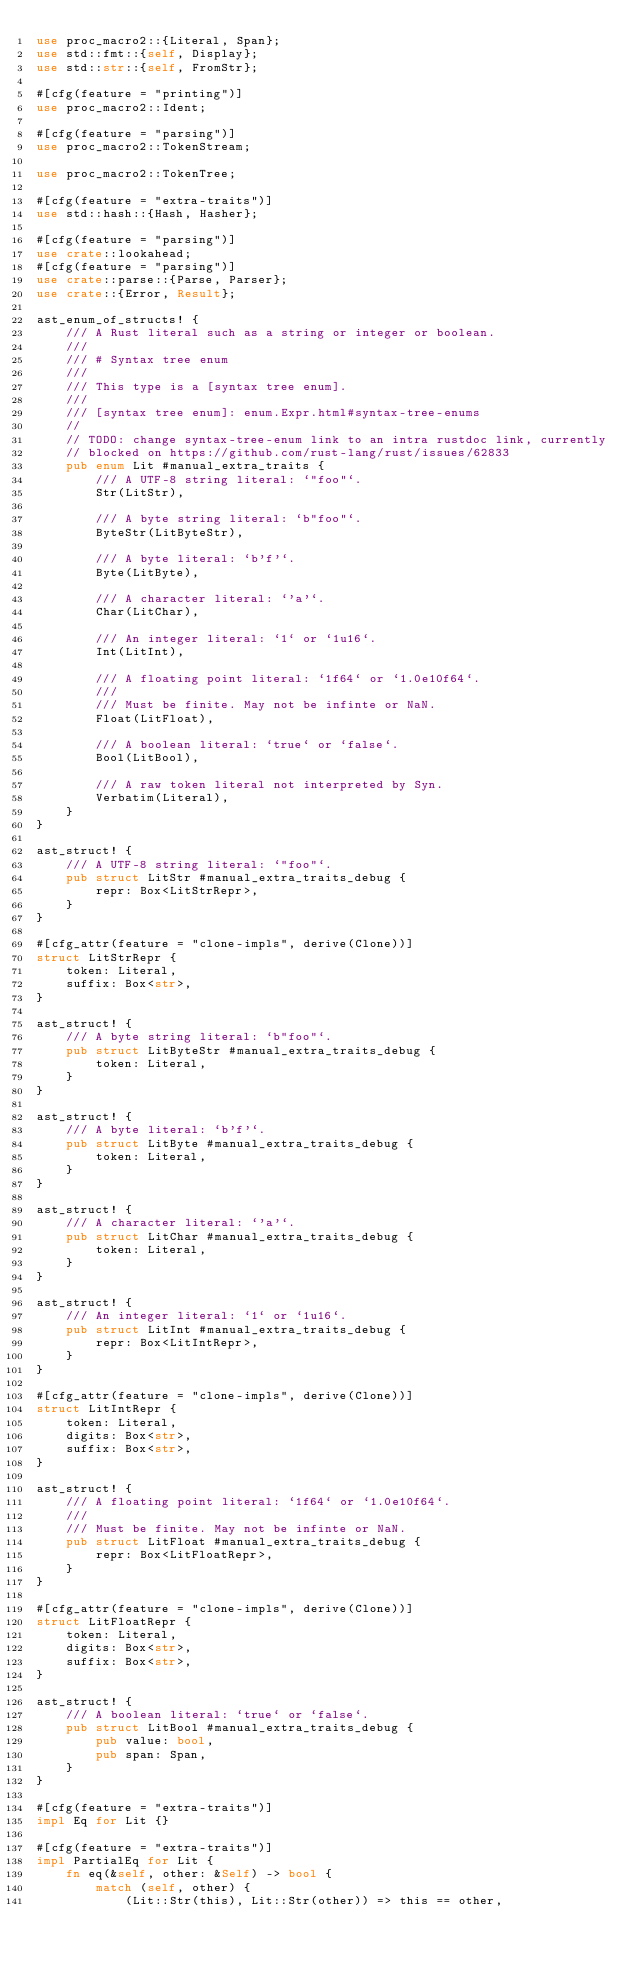<code> <loc_0><loc_0><loc_500><loc_500><_Rust_>use proc_macro2::{Literal, Span};
use std::fmt::{self, Display};
use std::str::{self, FromStr};

#[cfg(feature = "printing")]
use proc_macro2::Ident;

#[cfg(feature = "parsing")]
use proc_macro2::TokenStream;

use proc_macro2::TokenTree;

#[cfg(feature = "extra-traits")]
use std::hash::{Hash, Hasher};

#[cfg(feature = "parsing")]
use crate::lookahead;
#[cfg(feature = "parsing")]
use crate::parse::{Parse, Parser};
use crate::{Error, Result};

ast_enum_of_structs! {
    /// A Rust literal such as a string or integer or boolean.
    ///
    /// # Syntax tree enum
    ///
    /// This type is a [syntax tree enum].
    ///
    /// [syntax tree enum]: enum.Expr.html#syntax-tree-enums
    //
    // TODO: change syntax-tree-enum link to an intra rustdoc link, currently
    // blocked on https://github.com/rust-lang/rust/issues/62833
    pub enum Lit #manual_extra_traits {
        /// A UTF-8 string literal: `"foo"`.
        Str(LitStr),

        /// A byte string literal: `b"foo"`.
        ByteStr(LitByteStr),

        /// A byte literal: `b'f'`.
        Byte(LitByte),

        /// A character literal: `'a'`.
        Char(LitChar),

        /// An integer literal: `1` or `1u16`.
        Int(LitInt),

        /// A floating point literal: `1f64` or `1.0e10f64`.
        ///
        /// Must be finite. May not be infinte or NaN.
        Float(LitFloat),

        /// A boolean literal: `true` or `false`.
        Bool(LitBool),

        /// A raw token literal not interpreted by Syn.
        Verbatim(Literal),
    }
}

ast_struct! {
    /// A UTF-8 string literal: `"foo"`.
    pub struct LitStr #manual_extra_traits_debug {
        repr: Box<LitStrRepr>,
    }
}

#[cfg_attr(feature = "clone-impls", derive(Clone))]
struct LitStrRepr {
    token: Literal,
    suffix: Box<str>,
}

ast_struct! {
    /// A byte string literal: `b"foo"`.
    pub struct LitByteStr #manual_extra_traits_debug {
        token: Literal,
    }
}

ast_struct! {
    /// A byte literal: `b'f'`.
    pub struct LitByte #manual_extra_traits_debug {
        token: Literal,
    }
}

ast_struct! {
    /// A character literal: `'a'`.
    pub struct LitChar #manual_extra_traits_debug {
        token: Literal,
    }
}

ast_struct! {
    /// An integer literal: `1` or `1u16`.
    pub struct LitInt #manual_extra_traits_debug {
        repr: Box<LitIntRepr>,
    }
}

#[cfg_attr(feature = "clone-impls", derive(Clone))]
struct LitIntRepr {
    token: Literal,
    digits: Box<str>,
    suffix: Box<str>,
}

ast_struct! {
    /// A floating point literal: `1f64` or `1.0e10f64`.
    ///
    /// Must be finite. May not be infinte or NaN.
    pub struct LitFloat #manual_extra_traits_debug {
        repr: Box<LitFloatRepr>,
    }
}

#[cfg_attr(feature = "clone-impls", derive(Clone))]
struct LitFloatRepr {
    token: Literal,
    digits: Box<str>,
    suffix: Box<str>,
}

ast_struct! {
    /// A boolean literal: `true` or `false`.
    pub struct LitBool #manual_extra_traits_debug {
        pub value: bool,
        pub span: Span,
    }
}

#[cfg(feature = "extra-traits")]
impl Eq for Lit {}

#[cfg(feature = "extra-traits")]
impl PartialEq for Lit {
    fn eq(&self, other: &Self) -> bool {
        match (self, other) {
            (Lit::Str(this), Lit::Str(other)) => this == other,</code> 